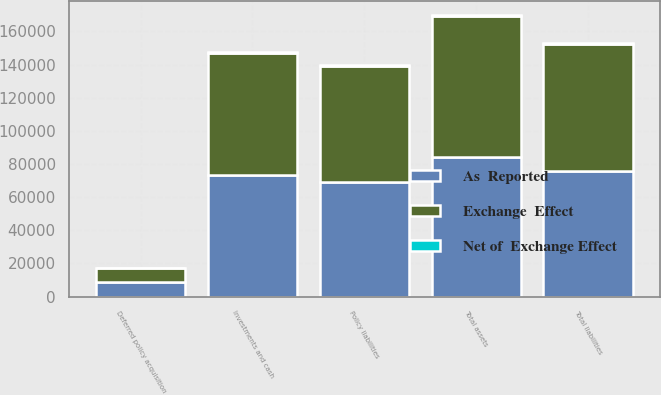<chart> <loc_0><loc_0><loc_500><loc_500><stacked_bar_chart><ecel><fcel>Investments and cash<fcel>Deferred policy acquisition<fcel>Total assets<fcel>Policy liabilities<fcel>Total liabilities<nl><fcel>As  Reported<fcel>73192<fcel>8533<fcel>84106<fcel>69245<fcel>75689<nl><fcel>Net of  Exchange Effect<fcel>714<fcel>69<fcel>799<fcel>729<fcel>778<nl><fcel>Exchange  Effect<fcel>73906<fcel>8602<fcel>84905<fcel>69974<fcel>76467<nl></chart> 